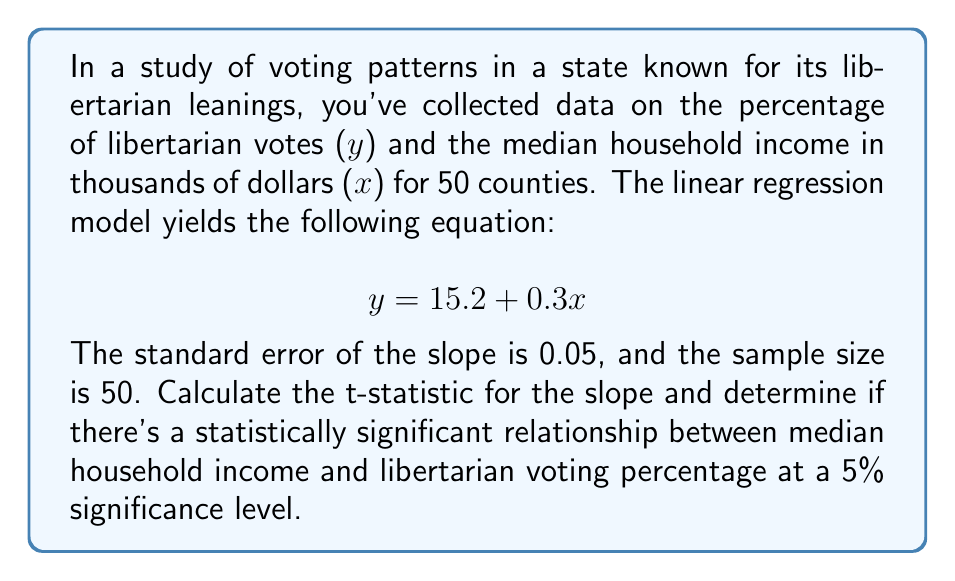Can you solve this math problem? 1. Given information:
   - Regression equation: $y = 15.2 + 0.3x$
   - Standard error of slope (SE): 0.05
   - Sample size (n): 50

2. Calculate the t-statistic for the slope:
   $$ t = \frac{\text{slope}}{\text{SE(slope)}} = \frac{0.3}{0.05} = 6 $$

3. Determine the degrees of freedom:
   $$ df = n - 2 = 50 - 2 = 48 $$

4. Find the critical t-value for a two-tailed test at 5% significance level with 48 df:
   $$ t_{critical} = \pm 2.011 $$

5. Compare the calculated t-statistic to the critical t-value:
   $$ |t| = 6 > 2.011 = t_{critical} $$

6. Since the absolute value of the calculated t-statistic is greater than the critical t-value, we reject the null hypothesis.

7. Conclusion: There is a statistically significant relationship between median household income and libertarian voting percentage at the 5% significance level.
Answer: Significant relationship (t = 6 > 2.011) 